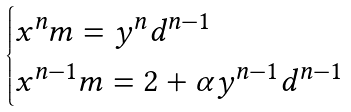Convert formula to latex. <formula><loc_0><loc_0><loc_500><loc_500>\begin{cases} x ^ { n } m = y ^ { n } d ^ { n - 1 } \\ x ^ { n - 1 } m = 2 + \alpha y ^ { n - 1 } d ^ { n - 1 } \end{cases}</formula> 